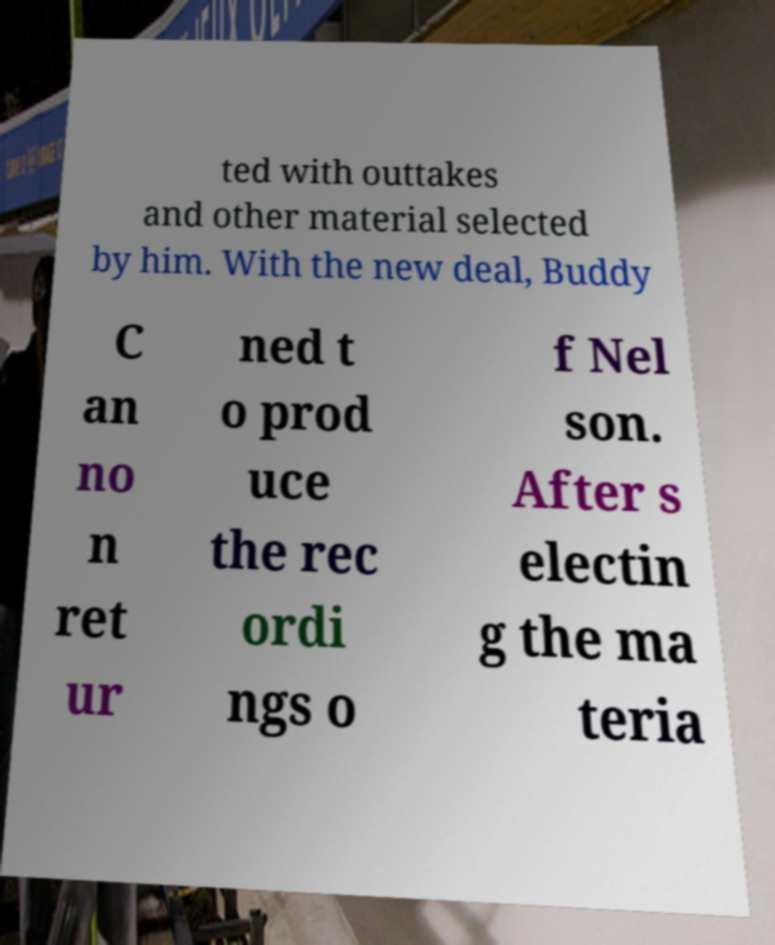Could you assist in decoding the text presented in this image and type it out clearly? ted with outtakes and other material selected by him. With the new deal, Buddy C an no n ret ur ned t o prod uce the rec ordi ngs o f Nel son. After s electin g the ma teria 